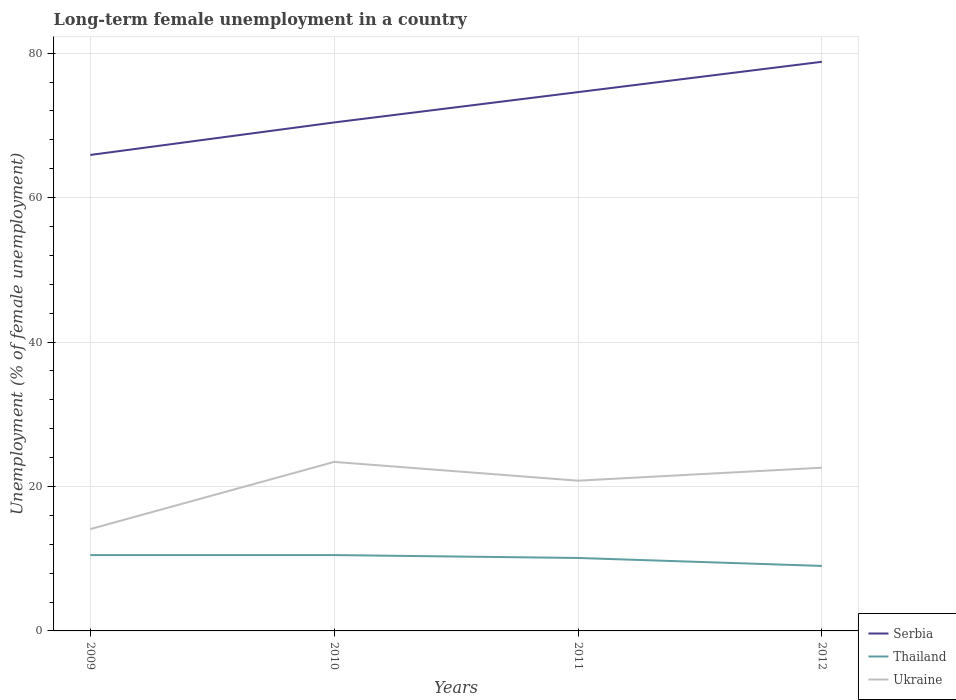In which year was the percentage of long-term unemployed female population in Thailand maximum?
Keep it short and to the point. 2012. What is the total percentage of long-term unemployed female population in Thailand in the graph?
Ensure brevity in your answer.  0.4. How many lines are there?
Your answer should be compact. 3. Does the graph contain any zero values?
Provide a short and direct response. No. Where does the legend appear in the graph?
Offer a very short reply. Bottom right. How many legend labels are there?
Offer a terse response. 3. What is the title of the graph?
Provide a short and direct response. Long-term female unemployment in a country. Does "Panama" appear as one of the legend labels in the graph?
Make the answer very short. No. What is the label or title of the Y-axis?
Offer a very short reply. Unemployment (% of female unemployment). What is the Unemployment (% of female unemployment) in Serbia in 2009?
Offer a terse response. 65.9. What is the Unemployment (% of female unemployment) of Ukraine in 2009?
Offer a terse response. 14.1. What is the Unemployment (% of female unemployment) in Serbia in 2010?
Ensure brevity in your answer.  70.4. What is the Unemployment (% of female unemployment) of Ukraine in 2010?
Make the answer very short. 23.4. What is the Unemployment (% of female unemployment) in Serbia in 2011?
Keep it short and to the point. 74.6. What is the Unemployment (% of female unemployment) in Thailand in 2011?
Your answer should be compact. 10.1. What is the Unemployment (% of female unemployment) in Ukraine in 2011?
Give a very brief answer. 20.8. What is the Unemployment (% of female unemployment) in Serbia in 2012?
Provide a succinct answer. 78.8. What is the Unemployment (% of female unemployment) of Thailand in 2012?
Make the answer very short. 9. What is the Unemployment (% of female unemployment) of Ukraine in 2012?
Offer a terse response. 22.6. Across all years, what is the maximum Unemployment (% of female unemployment) in Serbia?
Make the answer very short. 78.8. Across all years, what is the maximum Unemployment (% of female unemployment) in Thailand?
Your answer should be compact. 10.5. Across all years, what is the maximum Unemployment (% of female unemployment) of Ukraine?
Offer a terse response. 23.4. Across all years, what is the minimum Unemployment (% of female unemployment) in Serbia?
Your answer should be very brief. 65.9. Across all years, what is the minimum Unemployment (% of female unemployment) in Ukraine?
Ensure brevity in your answer.  14.1. What is the total Unemployment (% of female unemployment) in Serbia in the graph?
Give a very brief answer. 289.7. What is the total Unemployment (% of female unemployment) of Thailand in the graph?
Your response must be concise. 40.1. What is the total Unemployment (% of female unemployment) in Ukraine in the graph?
Offer a very short reply. 80.9. What is the difference between the Unemployment (% of female unemployment) in Serbia in 2009 and that in 2010?
Your answer should be very brief. -4.5. What is the difference between the Unemployment (% of female unemployment) of Thailand in 2009 and that in 2010?
Make the answer very short. 0. What is the difference between the Unemployment (% of female unemployment) in Serbia in 2009 and that in 2011?
Your answer should be compact. -8.7. What is the difference between the Unemployment (% of female unemployment) of Serbia in 2009 and that in 2012?
Keep it short and to the point. -12.9. What is the difference between the Unemployment (% of female unemployment) in Thailand in 2010 and that in 2012?
Your response must be concise. 1.5. What is the difference between the Unemployment (% of female unemployment) of Ukraine in 2010 and that in 2012?
Ensure brevity in your answer.  0.8. What is the difference between the Unemployment (% of female unemployment) of Ukraine in 2011 and that in 2012?
Your answer should be very brief. -1.8. What is the difference between the Unemployment (% of female unemployment) of Serbia in 2009 and the Unemployment (% of female unemployment) of Thailand in 2010?
Give a very brief answer. 55.4. What is the difference between the Unemployment (% of female unemployment) in Serbia in 2009 and the Unemployment (% of female unemployment) in Ukraine in 2010?
Your response must be concise. 42.5. What is the difference between the Unemployment (% of female unemployment) of Serbia in 2009 and the Unemployment (% of female unemployment) of Thailand in 2011?
Ensure brevity in your answer.  55.8. What is the difference between the Unemployment (% of female unemployment) of Serbia in 2009 and the Unemployment (% of female unemployment) of Ukraine in 2011?
Give a very brief answer. 45.1. What is the difference between the Unemployment (% of female unemployment) of Thailand in 2009 and the Unemployment (% of female unemployment) of Ukraine in 2011?
Give a very brief answer. -10.3. What is the difference between the Unemployment (% of female unemployment) in Serbia in 2009 and the Unemployment (% of female unemployment) in Thailand in 2012?
Provide a succinct answer. 56.9. What is the difference between the Unemployment (% of female unemployment) in Serbia in 2009 and the Unemployment (% of female unemployment) in Ukraine in 2012?
Offer a very short reply. 43.3. What is the difference between the Unemployment (% of female unemployment) in Serbia in 2010 and the Unemployment (% of female unemployment) in Thailand in 2011?
Keep it short and to the point. 60.3. What is the difference between the Unemployment (% of female unemployment) in Serbia in 2010 and the Unemployment (% of female unemployment) in Ukraine in 2011?
Give a very brief answer. 49.6. What is the difference between the Unemployment (% of female unemployment) in Serbia in 2010 and the Unemployment (% of female unemployment) in Thailand in 2012?
Ensure brevity in your answer.  61.4. What is the difference between the Unemployment (% of female unemployment) in Serbia in 2010 and the Unemployment (% of female unemployment) in Ukraine in 2012?
Offer a very short reply. 47.8. What is the difference between the Unemployment (% of female unemployment) of Thailand in 2010 and the Unemployment (% of female unemployment) of Ukraine in 2012?
Keep it short and to the point. -12.1. What is the difference between the Unemployment (% of female unemployment) in Serbia in 2011 and the Unemployment (% of female unemployment) in Thailand in 2012?
Ensure brevity in your answer.  65.6. What is the difference between the Unemployment (% of female unemployment) in Serbia in 2011 and the Unemployment (% of female unemployment) in Ukraine in 2012?
Keep it short and to the point. 52. What is the difference between the Unemployment (% of female unemployment) in Thailand in 2011 and the Unemployment (% of female unemployment) in Ukraine in 2012?
Offer a very short reply. -12.5. What is the average Unemployment (% of female unemployment) in Serbia per year?
Ensure brevity in your answer.  72.42. What is the average Unemployment (% of female unemployment) of Thailand per year?
Make the answer very short. 10.03. What is the average Unemployment (% of female unemployment) in Ukraine per year?
Offer a terse response. 20.23. In the year 2009, what is the difference between the Unemployment (% of female unemployment) in Serbia and Unemployment (% of female unemployment) in Thailand?
Offer a terse response. 55.4. In the year 2009, what is the difference between the Unemployment (% of female unemployment) of Serbia and Unemployment (% of female unemployment) of Ukraine?
Your answer should be compact. 51.8. In the year 2009, what is the difference between the Unemployment (% of female unemployment) of Thailand and Unemployment (% of female unemployment) of Ukraine?
Provide a succinct answer. -3.6. In the year 2010, what is the difference between the Unemployment (% of female unemployment) in Serbia and Unemployment (% of female unemployment) in Thailand?
Your response must be concise. 59.9. In the year 2010, what is the difference between the Unemployment (% of female unemployment) of Serbia and Unemployment (% of female unemployment) of Ukraine?
Your answer should be compact. 47. In the year 2010, what is the difference between the Unemployment (% of female unemployment) of Thailand and Unemployment (% of female unemployment) of Ukraine?
Provide a short and direct response. -12.9. In the year 2011, what is the difference between the Unemployment (% of female unemployment) in Serbia and Unemployment (% of female unemployment) in Thailand?
Ensure brevity in your answer.  64.5. In the year 2011, what is the difference between the Unemployment (% of female unemployment) in Serbia and Unemployment (% of female unemployment) in Ukraine?
Ensure brevity in your answer.  53.8. In the year 2011, what is the difference between the Unemployment (% of female unemployment) of Thailand and Unemployment (% of female unemployment) of Ukraine?
Offer a very short reply. -10.7. In the year 2012, what is the difference between the Unemployment (% of female unemployment) in Serbia and Unemployment (% of female unemployment) in Thailand?
Provide a succinct answer. 69.8. In the year 2012, what is the difference between the Unemployment (% of female unemployment) of Serbia and Unemployment (% of female unemployment) of Ukraine?
Give a very brief answer. 56.2. What is the ratio of the Unemployment (% of female unemployment) of Serbia in 2009 to that in 2010?
Offer a terse response. 0.94. What is the ratio of the Unemployment (% of female unemployment) in Ukraine in 2009 to that in 2010?
Keep it short and to the point. 0.6. What is the ratio of the Unemployment (% of female unemployment) of Serbia in 2009 to that in 2011?
Offer a very short reply. 0.88. What is the ratio of the Unemployment (% of female unemployment) in Thailand in 2009 to that in 2011?
Your answer should be compact. 1.04. What is the ratio of the Unemployment (% of female unemployment) of Ukraine in 2009 to that in 2011?
Ensure brevity in your answer.  0.68. What is the ratio of the Unemployment (% of female unemployment) in Serbia in 2009 to that in 2012?
Your response must be concise. 0.84. What is the ratio of the Unemployment (% of female unemployment) in Ukraine in 2009 to that in 2012?
Make the answer very short. 0.62. What is the ratio of the Unemployment (% of female unemployment) of Serbia in 2010 to that in 2011?
Keep it short and to the point. 0.94. What is the ratio of the Unemployment (% of female unemployment) in Thailand in 2010 to that in 2011?
Your answer should be very brief. 1.04. What is the ratio of the Unemployment (% of female unemployment) of Serbia in 2010 to that in 2012?
Give a very brief answer. 0.89. What is the ratio of the Unemployment (% of female unemployment) in Ukraine in 2010 to that in 2012?
Offer a very short reply. 1.04. What is the ratio of the Unemployment (% of female unemployment) in Serbia in 2011 to that in 2012?
Your response must be concise. 0.95. What is the ratio of the Unemployment (% of female unemployment) in Thailand in 2011 to that in 2012?
Your answer should be compact. 1.12. What is the ratio of the Unemployment (% of female unemployment) in Ukraine in 2011 to that in 2012?
Provide a succinct answer. 0.92. What is the difference between the highest and the second highest Unemployment (% of female unemployment) in Serbia?
Give a very brief answer. 4.2. What is the difference between the highest and the lowest Unemployment (% of female unemployment) of Serbia?
Your answer should be compact. 12.9. What is the difference between the highest and the lowest Unemployment (% of female unemployment) of Thailand?
Keep it short and to the point. 1.5. 